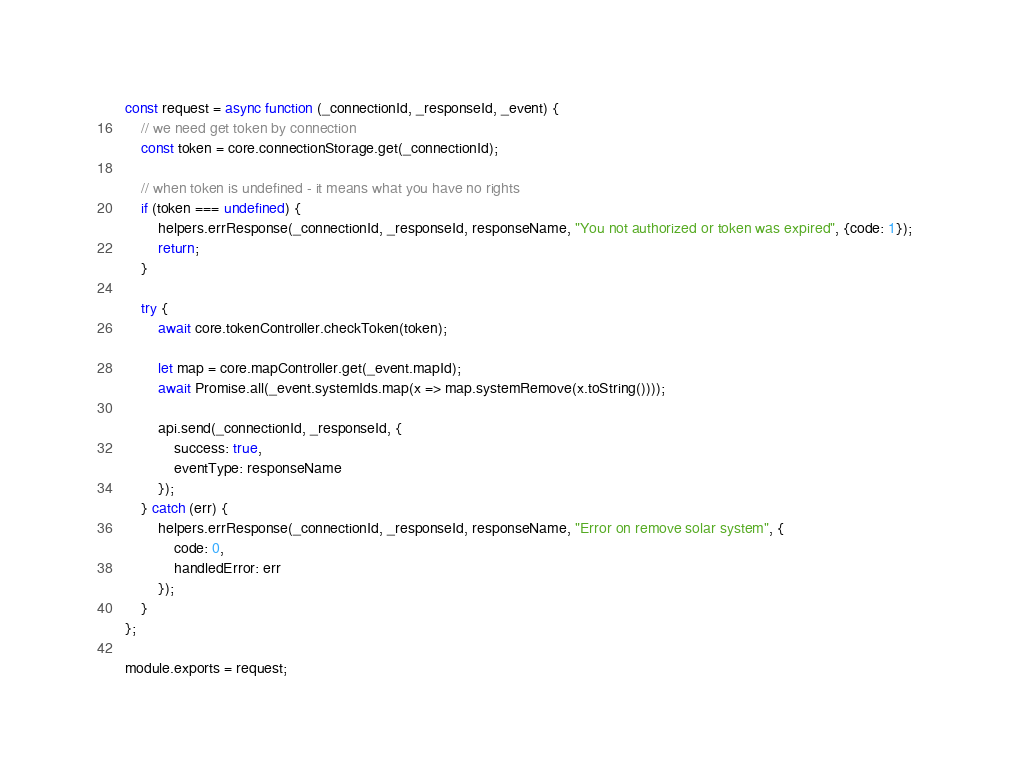<code> <loc_0><loc_0><loc_500><loc_500><_JavaScript_>const request = async function (_connectionId, _responseId, _event) {
    // we need get token by connection
    const token = core.connectionStorage.get(_connectionId);

    // when token is undefined - it means what you have no rights
    if (token === undefined) {
        helpers.errResponse(_connectionId, _responseId, responseName, "You not authorized or token was expired", {code: 1});
        return;
    }

    try {
        await core.tokenController.checkToken(token);

        let map = core.mapController.get(_event.mapId);
        await Promise.all(_event.systemIds.map(x => map.systemRemove(x.toString())));

        api.send(_connectionId, _responseId, {
            success: true,
            eventType: responseName
        });
    } catch (err) {
        helpers.errResponse(_connectionId, _responseId, responseName, "Error on remove solar system", {
            code: 0,
            handledError: err
        });
    }
};

module.exports = request;</code> 